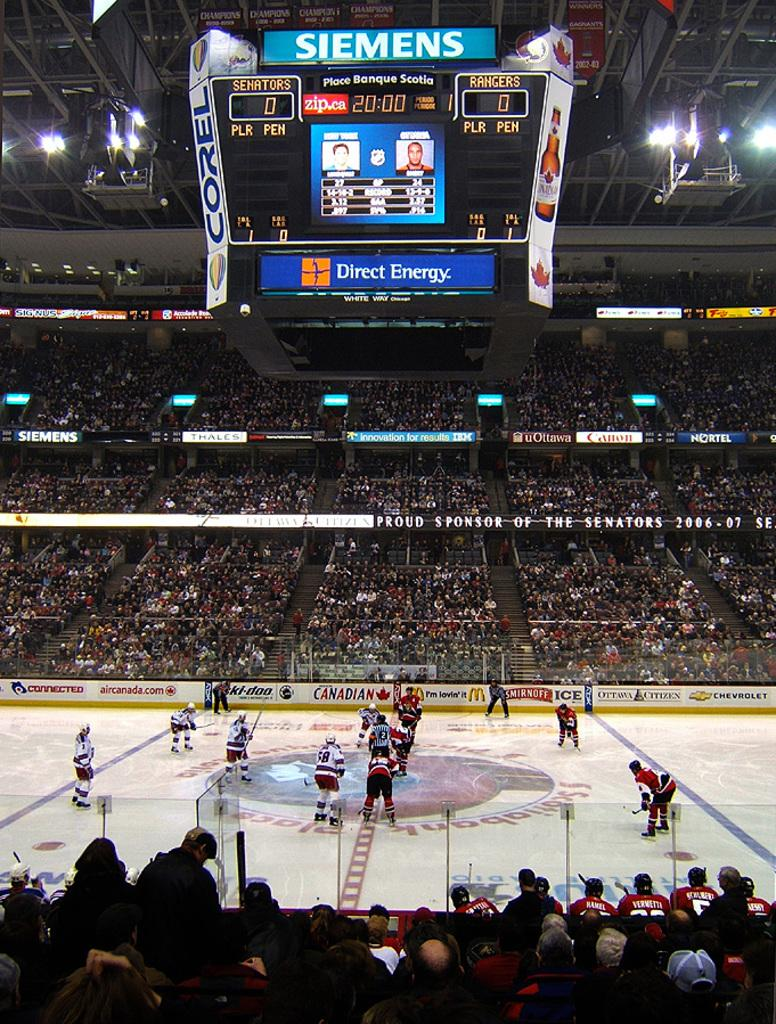<image>
Render a clear and concise summary of the photo. A hockey game being played with scoreboard ad for Direct energy and Siemens 